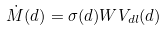Convert formula to latex. <formula><loc_0><loc_0><loc_500><loc_500>\dot { M } ( d ) = \sigma ( d ) W V _ { d l } ( d )</formula> 